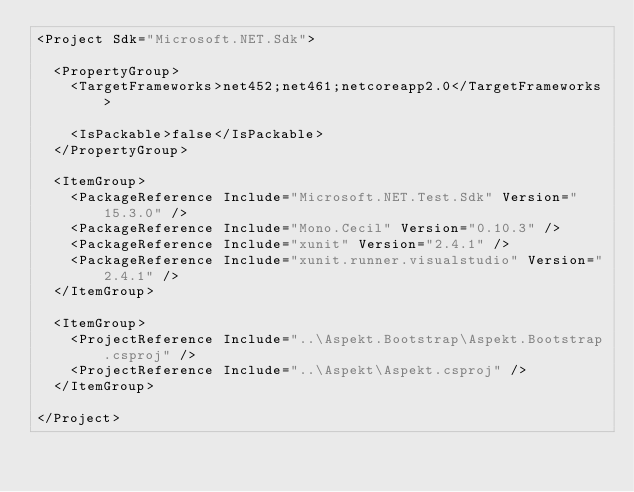Convert code to text. <code><loc_0><loc_0><loc_500><loc_500><_XML_><Project Sdk="Microsoft.NET.Sdk">

  <PropertyGroup>
    <TargetFrameworks>net452;net461;netcoreapp2.0</TargetFrameworks>

    <IsPackable>false</IsPackable>
  </PropertyGroup>

  <ItemGroup>
    <PackageReference Include="Microsoft.NET.Test.Sdk" Version="15.3.0" />
    <PackageReference Include="Mono.Cecil" Version="0.10.3" />
    <PackageReference Include="xunit" Version="2.4.1" />
    <PackageReference Include="xunit.runner.visualstudio" Version="2.4.1" />
  </ItemGroup>

  <ItemGroup>
    <ProjectReference Include="..\Aspekt.Bootstrap\Aspekt.Bootstrap.csproj" />
    <ProjectReference Include="..\Aspekt\Aspekt.csproj" />
  </ItemGroup>

</Project>
</code> 